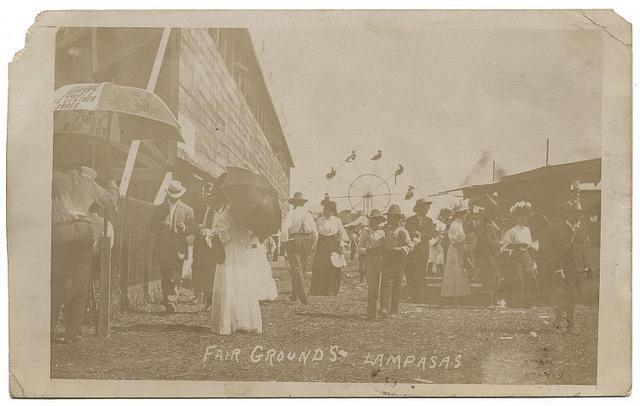How many umbrellas are there?
Give a very brief answer. 2. How many heart shapes are in this picture?
Give a very brief answer. 0. How many people can you see?
Give a very brief answer. 8. 